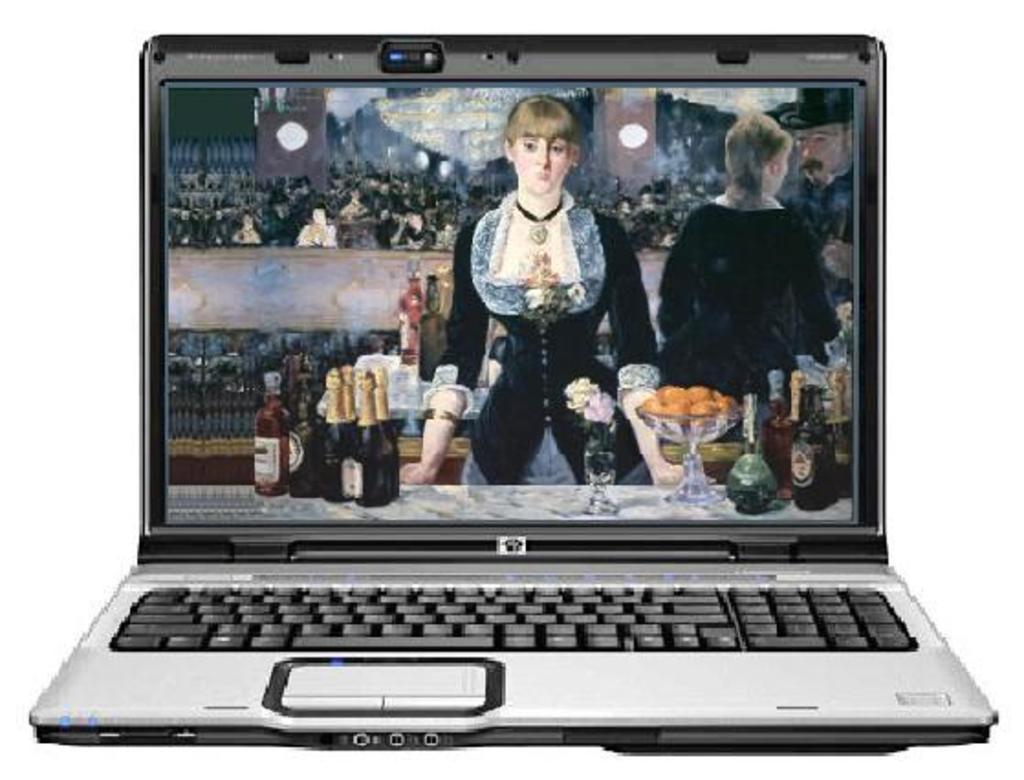In one or two sentences, can you explain what this image depicts? In this picture we can see a laptop. 